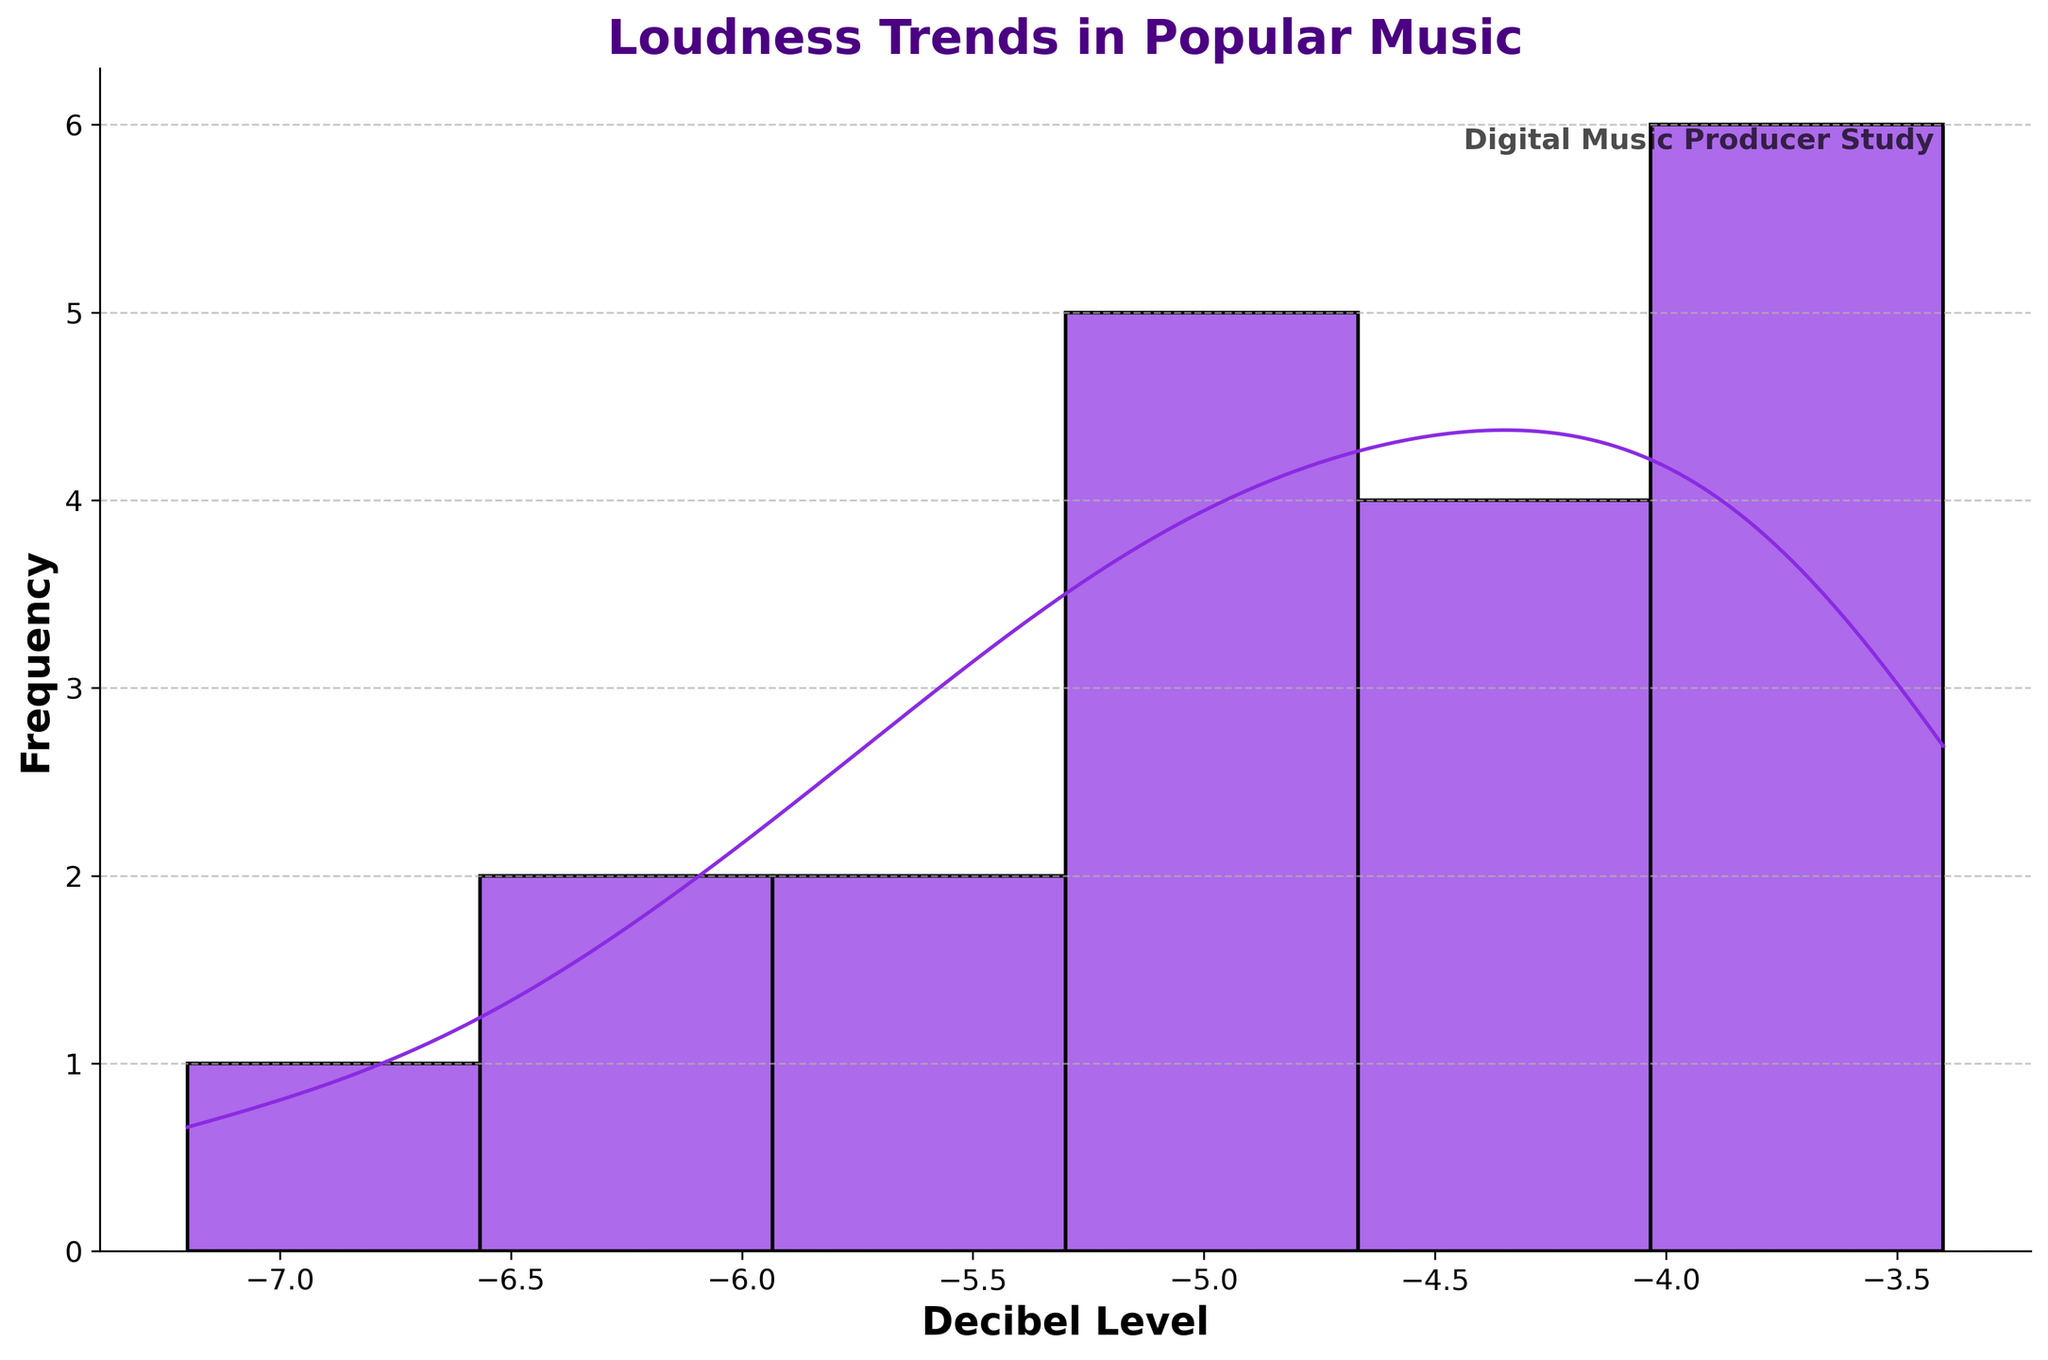What is the title of the figure? The title is usually found at the top of the figure, displayed in bold and larger fonts. It summarizes what the figure shows.
Answer: Loudness Trends in Popular Music What is the color of the histogram bars? The color of the histogram bars can be seen by looking at the bars themselves; they are usually filled with the same color throughout.
Answer: Purple What does the x-axis represent? The x-axis label is usually found at the bottom of the axis and indicates what the horizontal scale measures. In this case, it reflects the measure of loudness.
Answer: Decibel Level Which side of the decibel level contains the most data points? To determine which side of the decibel level contains the most data points, look at the height of the histogram bars; taller bars represent more data points. This can be found by visually inspecting the left and right sections of the histogram.
Answer: Left side Is there a notable peak in the density curve (KDE)? Observing the height and shape of the density curve over the x-axis, any notable peak will prominently stand out as the highest point or points in the curve.
Answer: Yes What is the approximate decibel level where the density curve peaks? To find the approximate decibel level where the KDE peaks, trace the highest point of the density curve down to the x-axis.
Answer: Around -4 dB How many songs have a decibel level lower than -6 dB? To find how many songs have a decibel level lower than -6 dB, look at the histogram bars to the left of -6 dB on the x-axis. The bars' height indicates the frequency of songs. Count or estimate the frequency.
Answer: 2 songs Is the distribution of decibel levels symmetrical? Symmetry in the distribution can be checked by seeing if the left and right sides of the histogram mirror each other closely. In this case, we would compare the bar heights and KDE shape.
Answer: No Are there any outlier songs based on their decibel levels? Outliers are typically identified by looking for bars that are isolated and far from the main cluster of bars on the histogram.
Answer: Yes How does the decibel level trend change around -3 dB? To determine how the decibel level trend changes around -3 dB, look at both the histogram bars and the KDE curve near this value. Analyze if there are more, fewer, or consistent bars and the slope of the KDE curve near this point.
Answer: The trend decreases around -3 dB 